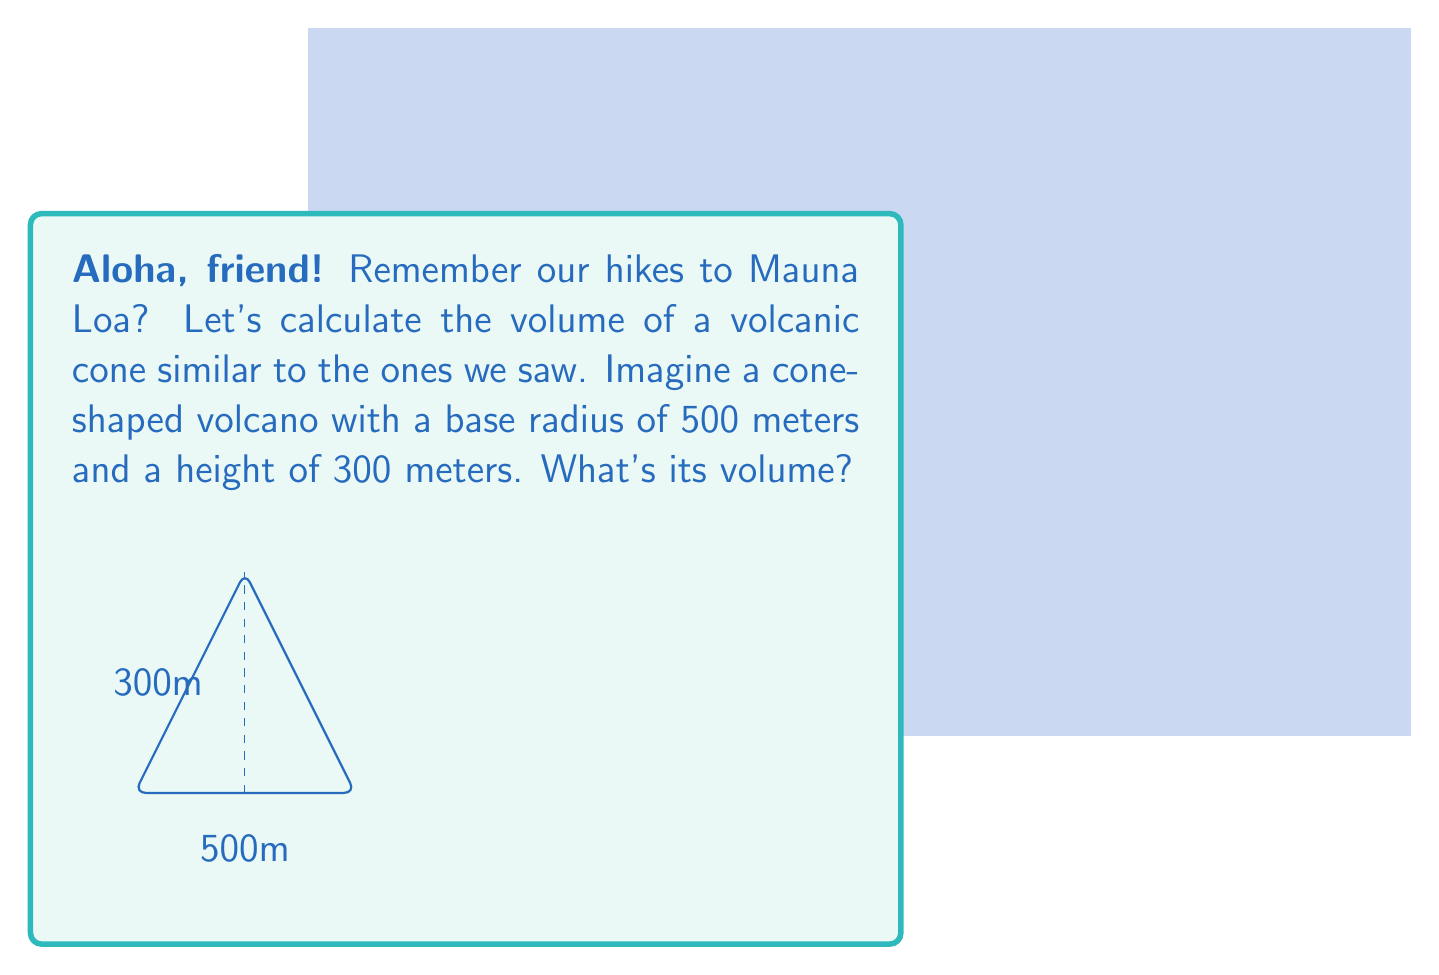Solve this math problem. Let's approach this step-by-step, using the formula for the volume of a cone:

1) The formula for the volume of a cone is:
   $$V = \frac{1}{3}\pi r^2 h$$
   where $r$ is the radius of the base and $h$ is the height of the cone.

2) We're given:
   $r = 500$ meters
   $h = 300$ meters

3) Let's substitute these values into our formula:
   $$V = \frac{1}{3}\pi (500\text{ m})^2 (300\text{ m})$$

4) Simplify the expression inside the parentheses:
   $$V = \frac{1}{3}\pi (250,000\text{ m}^2) (300\text{ m})$$

5) Multiply the numbers:
   $$V = \frac{1}{3}\pi (75,000,000\text{ m}^3)$$

6) Multiply by $\frac{1}{3}$:
   $$V = 25,000,000\pi\text{ m}^3$$

7) Use 3.14159 as an approximation for $\pi$:
   $$V \approx 25,000,000 \times 3.14159\text{ m}^3 = 78,539,750\text{ m}^3$$

8) Round to the nearest million cubic meters:
   $$V \approx 79,000,000\text{ m}^3$$
Answer: $79,000,000\text{ m}^3$ 